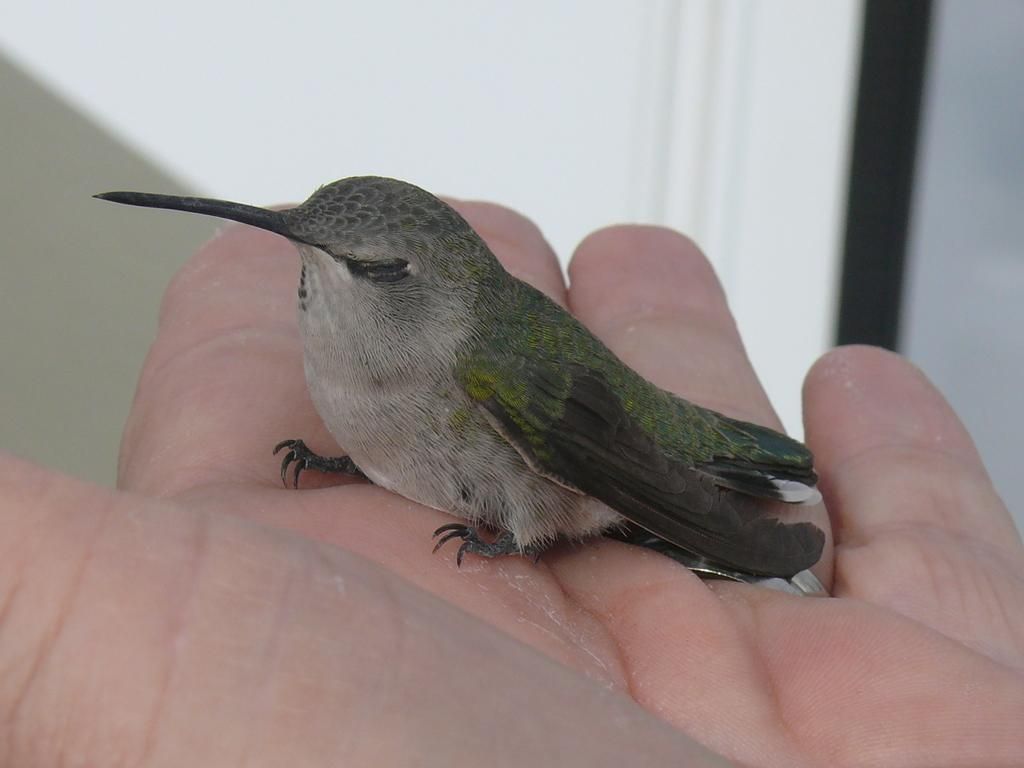What type of animal is in the image? There is a bird in the image. Where is the bird located? The bird is on a person's hand. What colors can be seen on the bird? The bird has green, black, and cream colors. What is the color scheme of the background in the image? The background of the image is in white and black colors. How many beds are visible in the image? There are no beds present in the image. What type of show is the bird performing in the image? There is no show or performance depicted in the image; it simply shows a bird on a person's hand. 